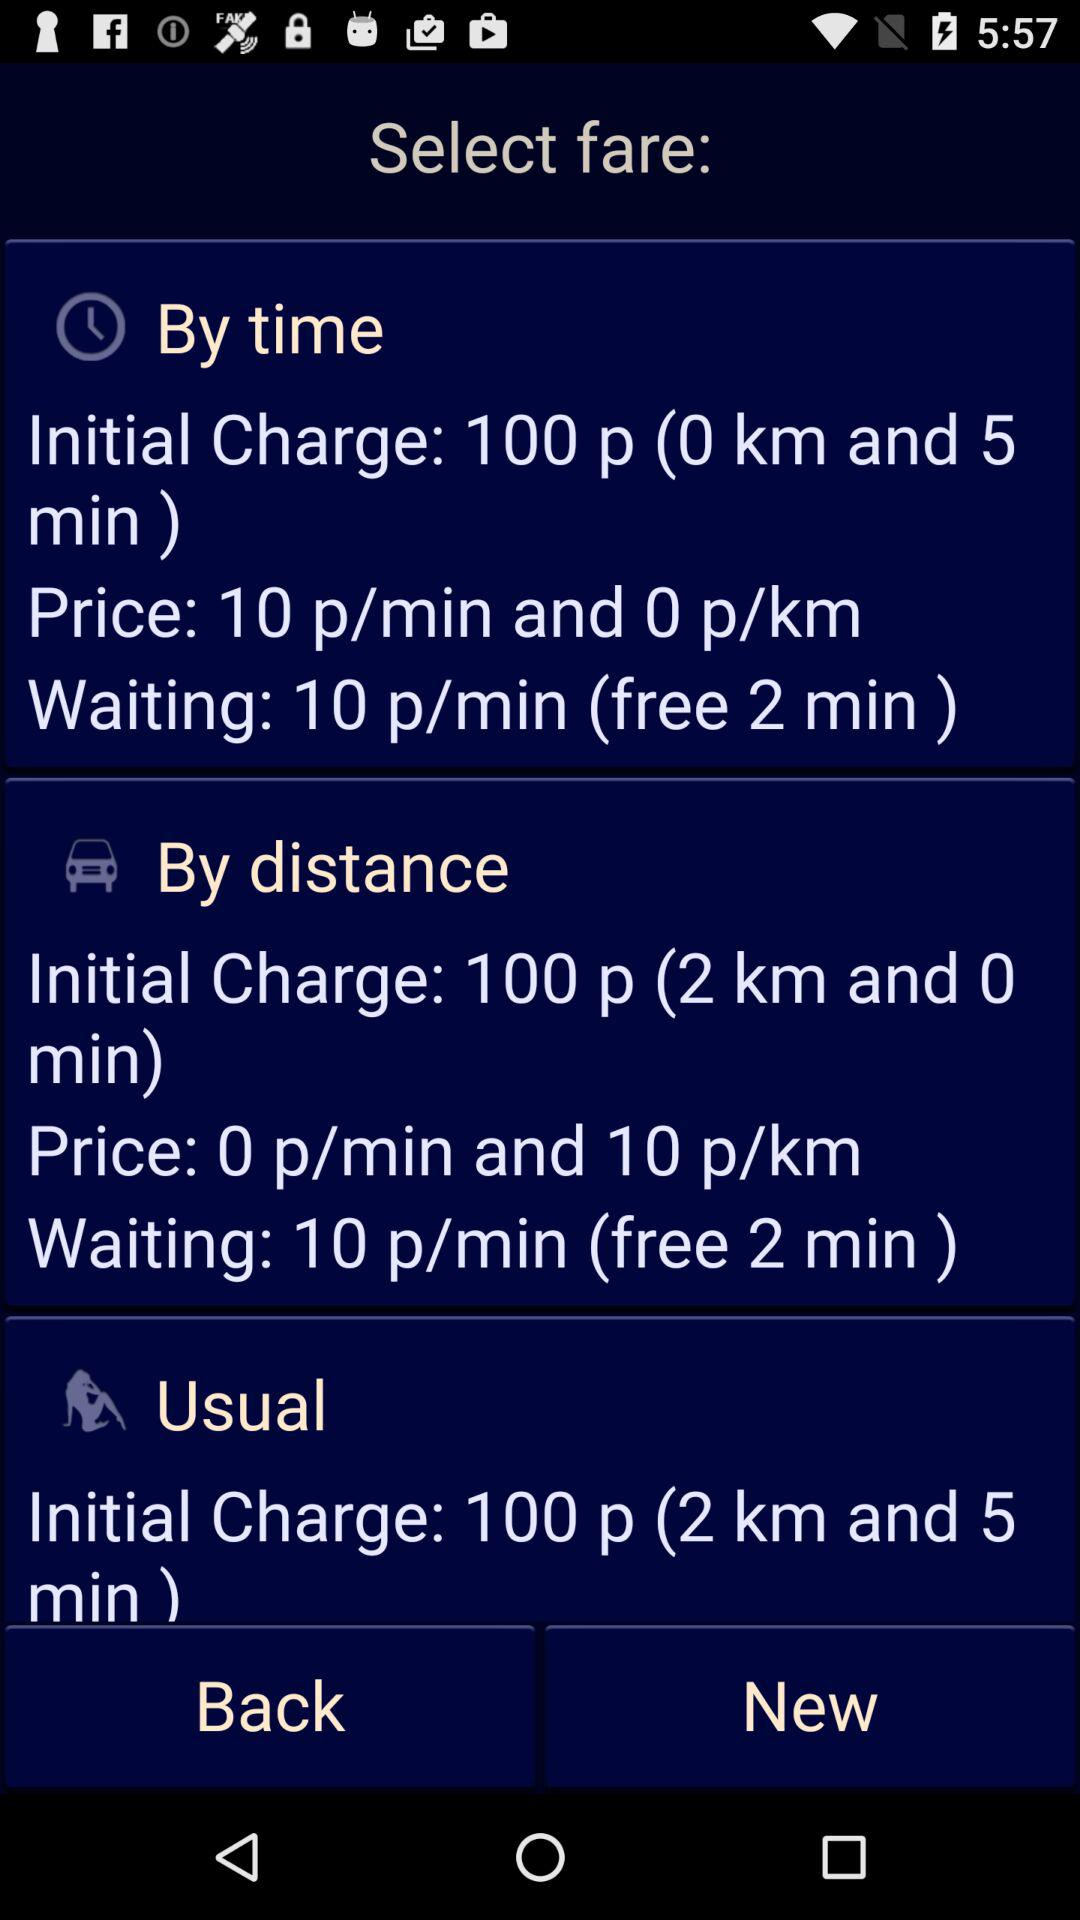What is the price per minute if travelling by time? The price per minute if travelling by time is 10 p. 